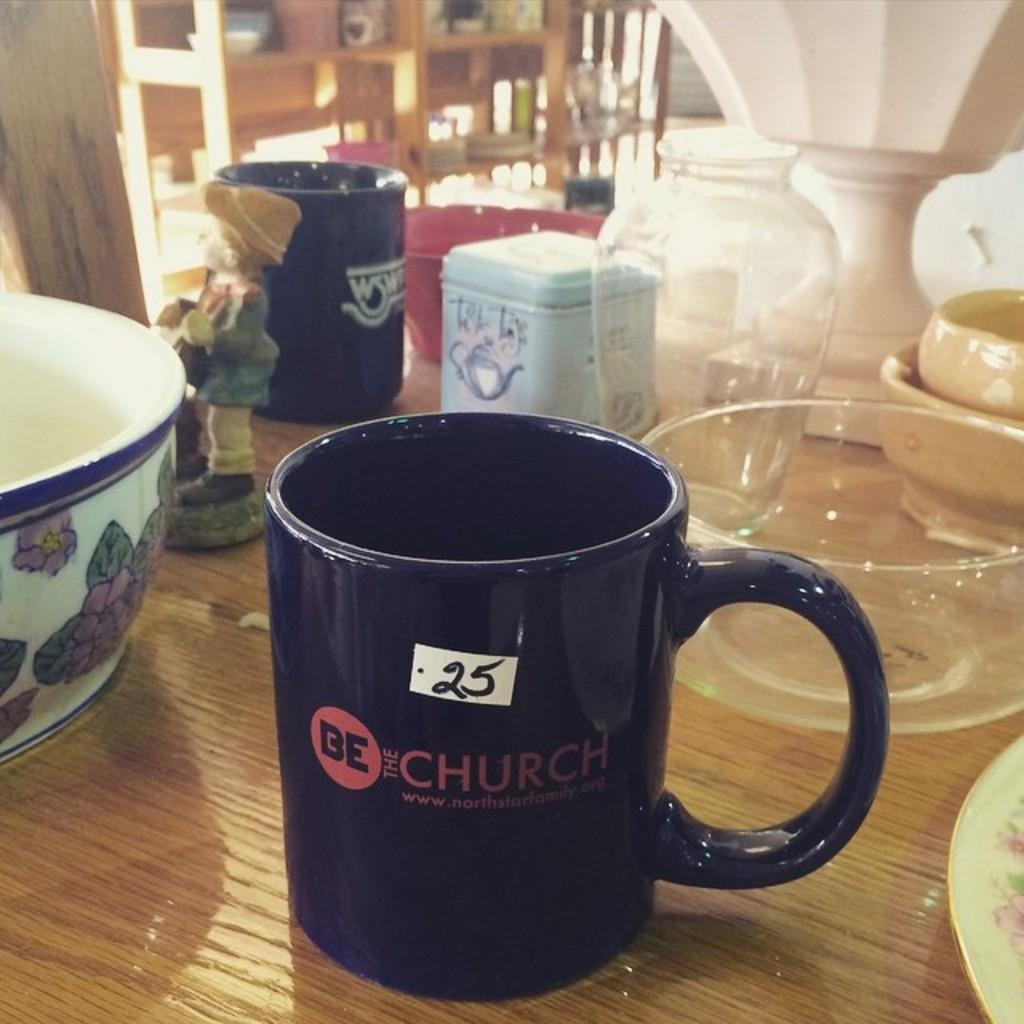What type of object can be seen in the image? There is a toy in the image. What other items are present on the table in the image? There are cups and bowls in the image. Can you describe any other objects on the table? There are other things on the table in the image. How would you describe the background of the image? The background of the image is blurry. What is the profit margin of the cake in the image? There is no cake present in the image, so it is not possible to determine the profit margin. 